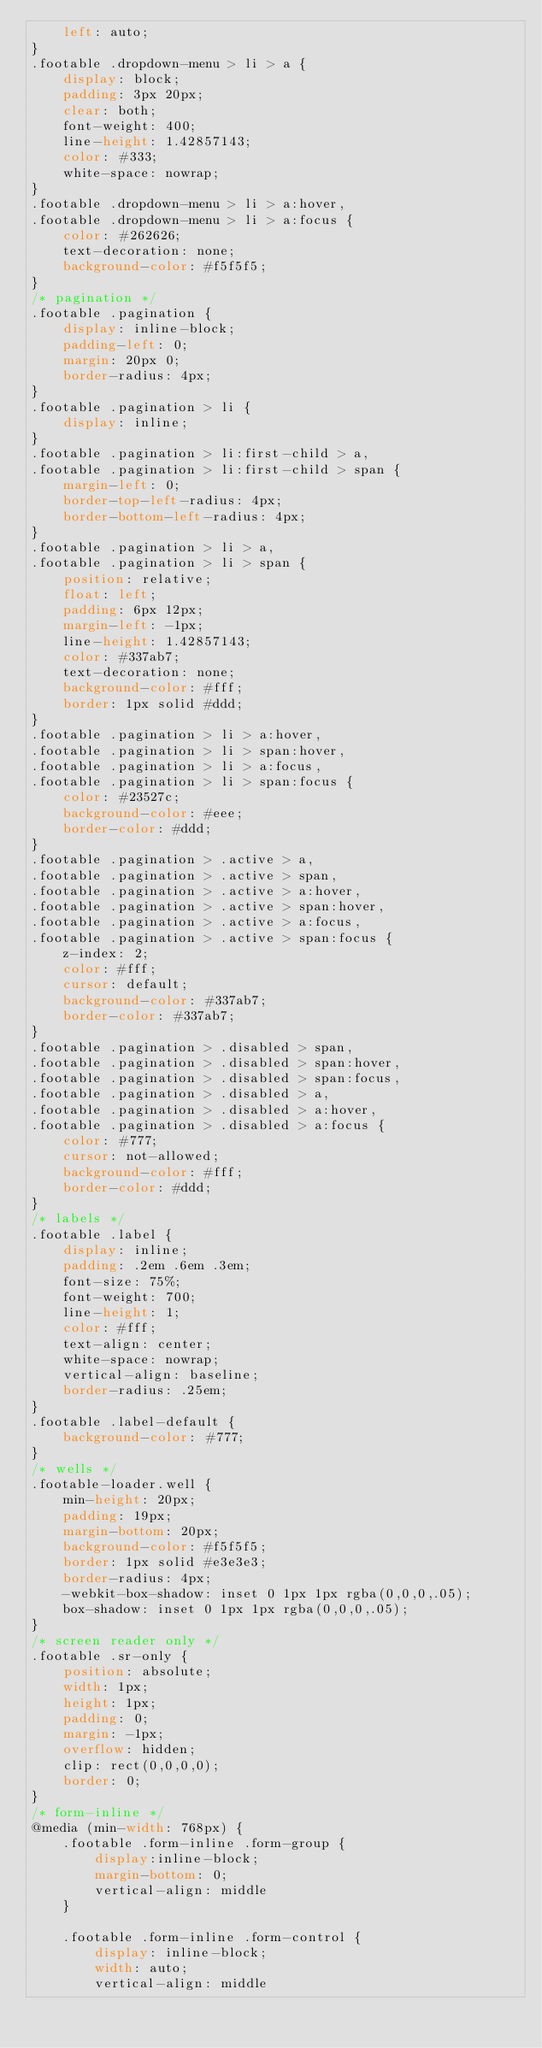Convert code to text. <code><loc_0><loc_0><loc_500><loc_500><_CSS_>	left: auto;
}
.footable .dropdown-menu > li > a {
	display: block;
	padding: 3px 20px;
	clear: both;
	font-weight: 400;
	line-height: 1.42857143;
	color: #333;
	white-space: nowrap;
}
.footable .dropdown-menu > li > a:hover,
.footable .dropdown-menu > li > a:focus {
	color: #262626;
	text-decoration: none;
	background-color: #f5f5f5;
}
/* pagination */
.footable .pagination {
	display: inline-block;
	padding-left: 0;
	margin: 20px 0;
	border-radius: 4px;
}
.footable .pagination > li {
	display: inline;
}
.footable .pagination > li:first-child > a,
.footable .pagination > li:first-child > span {
	margin-left: 0;
	border-top-left-radius: 4px;
	border-bottom-left-radius: 4px;
}
.footable .pagination > li > a,
.footable .pagination > li > span {
	position: relative;
	float: left;
	padding: 6px 12px;
	margin-left: -1px;
	line-height: 1.42857143;
	color: #337ab7;
	text-decoration: none;
	background-color: #fff;
	border: 1px solid #ddd;
}
.footable .pagination > li > a:hover,
.footable .pagination > li > span:hover,
.footable .pagination > li > a:focus,
.footable .pagination > li > span:focus {
	color: #23527c;
	background-color: #eee;
	border-color: #ddd;
}
.footable .pagination > .active > a,
.footable .pagination > .active > span,
.footable .pagination > .active > a:hover,
.footable .pagination > .active > span:hover,
.footable .pagination > .active > a:focus,
.footable .pagination > .active > span:focus {
	z-index: 2;
	color: #fff;
	cursor: default;
	background-color: #337ab7;
	border-color: #337ab7;
}
.footable .pagination > .disabled > span,
.footable .pagination > .disabled > span:hover,
.footable .pagination > .disabled > span:focus,
.footable .pagination > .disabled > a,
.footable .pagination > .disabled > a:hover,
.footable .pagination > .disabled > a:focus {
	color: #777;
	cursor: not-allowed;
	background-color: #fff;
	border-color: #ddd;
}
/* labels */
.footable .label {
	display: inline;
	padding: .2em .6em .3em;
	font-size: 75%;
	font-weight: 700;
	line-height: 1;
	color: #fff;
	text-align: center;
	white-space: nowrap;
	vertical-align: baseline;
	border-radius: .25em;
}
.footable .label-default {
	background-color: #777;
}
/* wells */
.footable-loader.well {
	min-height: 20px;
	padding: 19px;
	margin-bottom: 20px;
	background-color: #f5f5f5;
	border: 1px solid #e3e3e3;
	border-radius: 4px;
	-webkit-box-shadow: inset 0 1px 1px rgba(0,0,0,.05);
	box-shadow: inset 0 1px 1px rgba(0,0,0,.05);
}
/* screen reader only */
.footable .sr-only {
	position: absolute;
	width: 1px;
	height: 1px;
	padding: 0;
	margin: -1px;
	overflow: hidden;
	clip: rect(0,0,0,0);
	border: 0;
}
/* form-inline */
@media (min-width: 768px) {
	.footable .form-inline .form-group {
		display:inline-block;
		margin-bottom: 0;
		vertical-align: middle
	}

	.footable .form-inline .form-control {
		display: inline-block;
		width: auto;
		vertical-align: middle</code> 